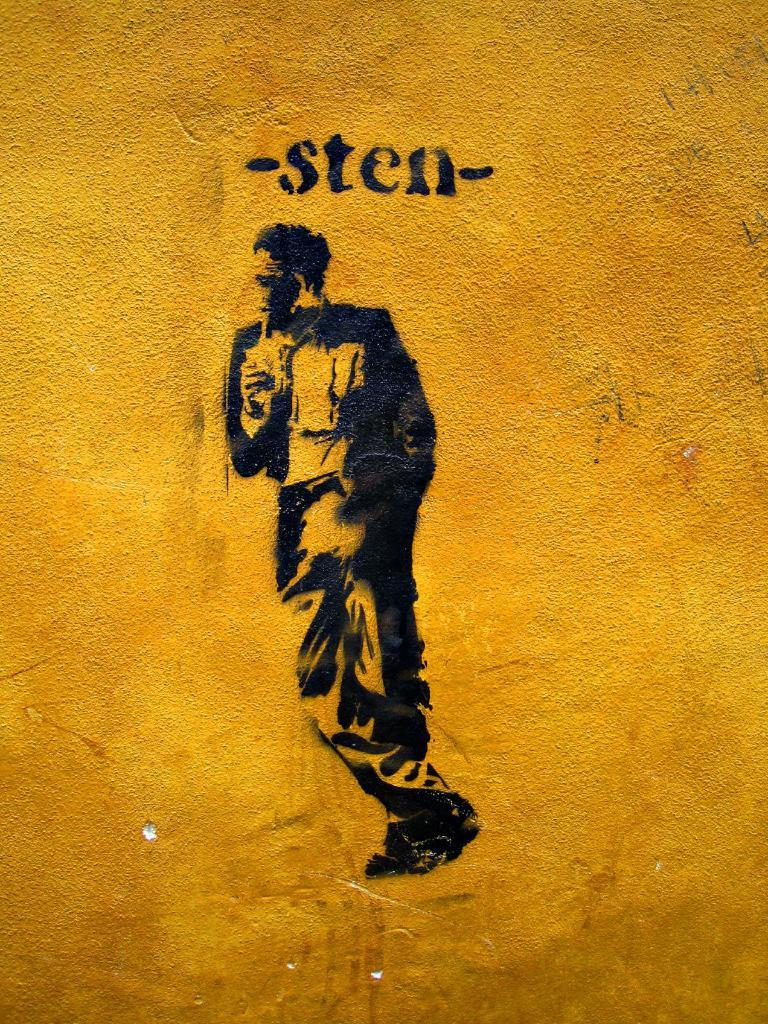<image>
Share a concise interpretation of the image provided. a mural on a wall that says 'sten' at the top 